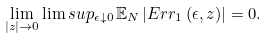Convert formula to latex. <formula><loc_0><loc_0><loc_500><loc_500>\lim _ { | z | \to 0 } { \lim s u p _ { \epsilon \downarrow 0 } } { \, \mathbb { E } _ { N } \left | E r r _ { 1 } \left ( \epsilon , z \right ) \right | } = 0 .</formula> 